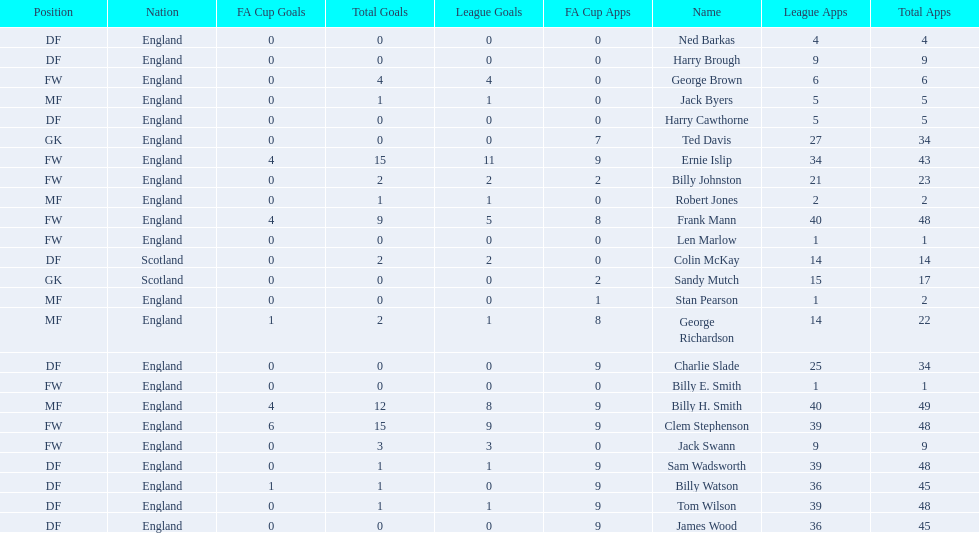How many players are fws? 8. 